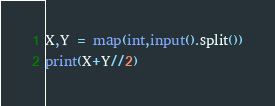Convert code to text. <code><loc_0><loc_0><loc_500><loc_500><_Python_>X,Y = map(int,input().split())
print(X+Y//2)</code> 